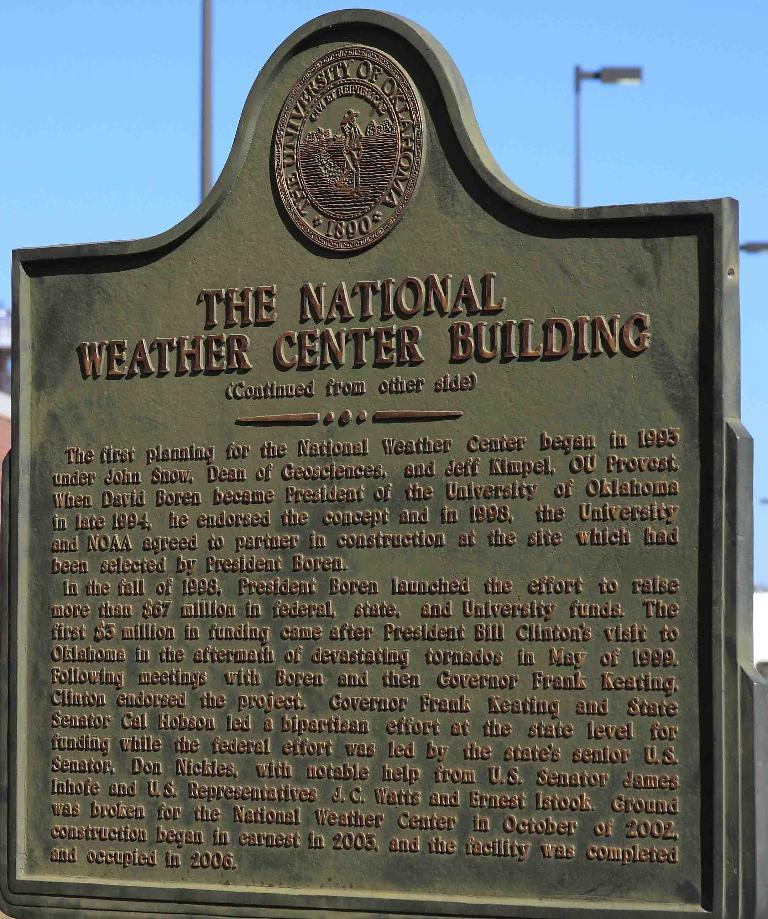<image>
Share a concise interpretation of the image provided. A 2-sided plaque commemorates The National Weather Center Building on The University of Oklahoma property. 